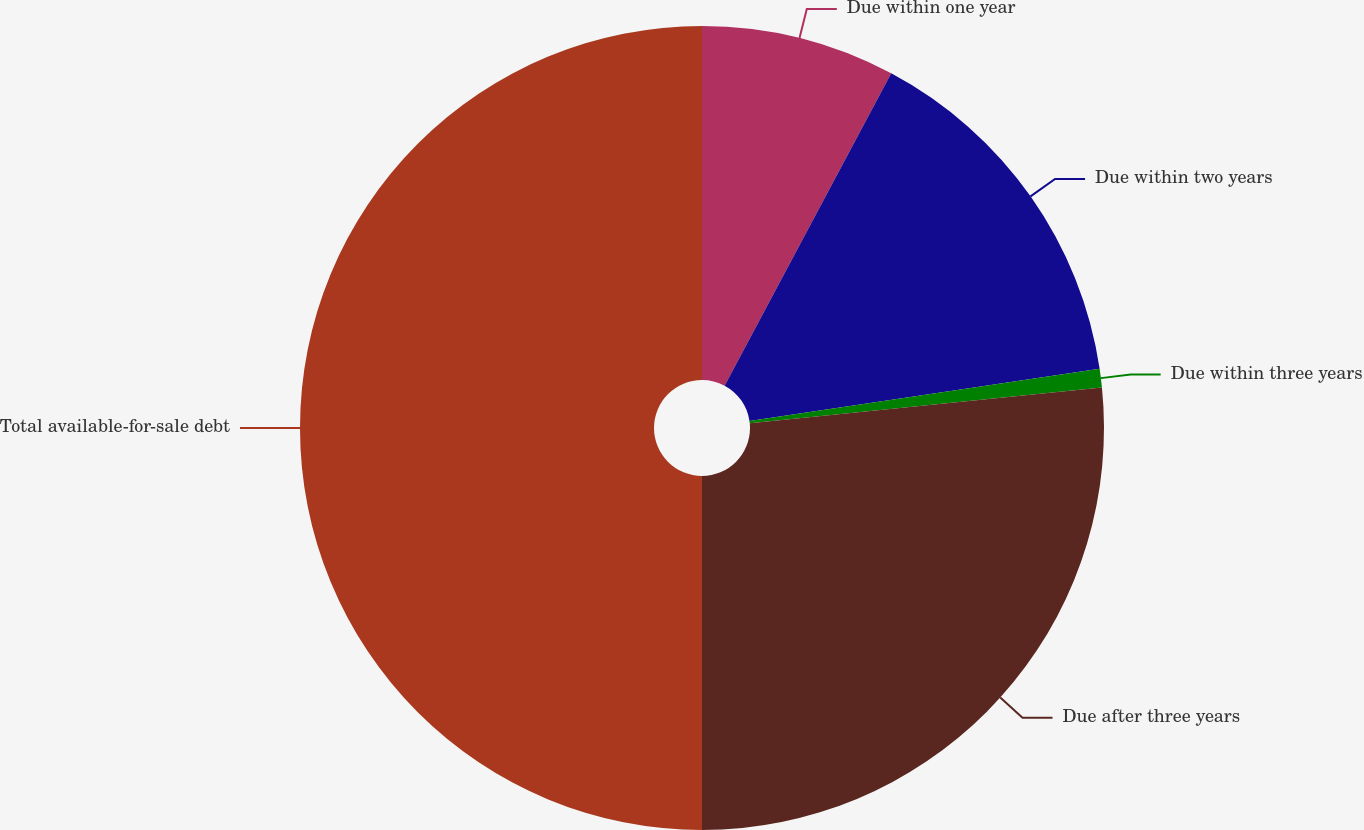Convert chart to OTSL. <chart><loc_0><loc_0><loc_500><loc_500><pie_chart><fcel>Due within one year<fcel>Due within two years<fcel>Due within three years<fcel>Due after three years<fcel>Total available-for-sale debt<nl><fcel>7.8%<fcel>14.85%<fcel>0.74%<fcel>26.61%<fcel>50.0%<nl></chart> 